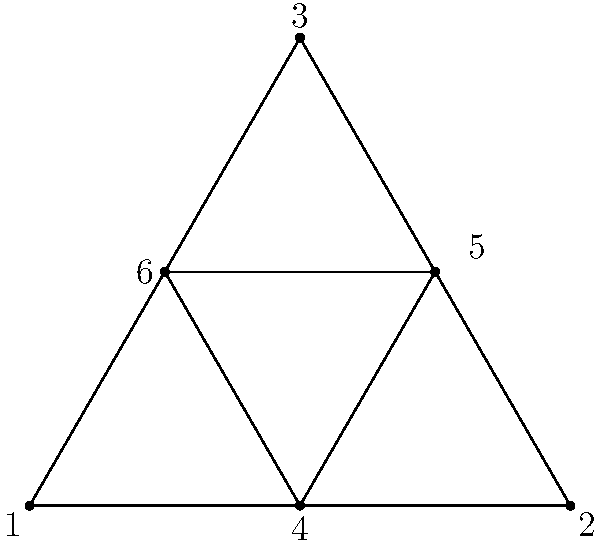For a PR event, you are arranging name tags in a triangular pattern. The outer triangle represents VIP guests, while the inner triangle represents speakers. How many unique arrangements are possible if you have 6 distinct name tags and want to ensure that no two arrangements are identical under rotation? Let's approach this step-by-step:

1) First, we need to understand what makes arrangements unique under rotation. For a triangle, rotations of 120° and 240° will produce the same arrangement, so we only need to consider one fixed position.

2) For the outer triangle (VIPs):
   - We have 6 choices for the first position
   - 5 choices for the second position
   - 4 choices for the third position
   
3) For the inner triangle (speakers):
   - We have 3 choices left for the first position
   - 2 choices for the second position
   - 1 choice for the last position
   
4) Using the multiplication principle, the total number of arrangements is:

   $$(6 \times 5 \times 4) \times (3 \times 2 \times 1) = 720$$

5) However, this count includes arrangements that are identical under rotation. To eliminate these, we need to divide by 3 (as there are 3 rotational symmetries in a triangle).

6) Therefore, the number of unique arrangements is:

   $$\frac{720}{3} = 240$$
Answer: 240 